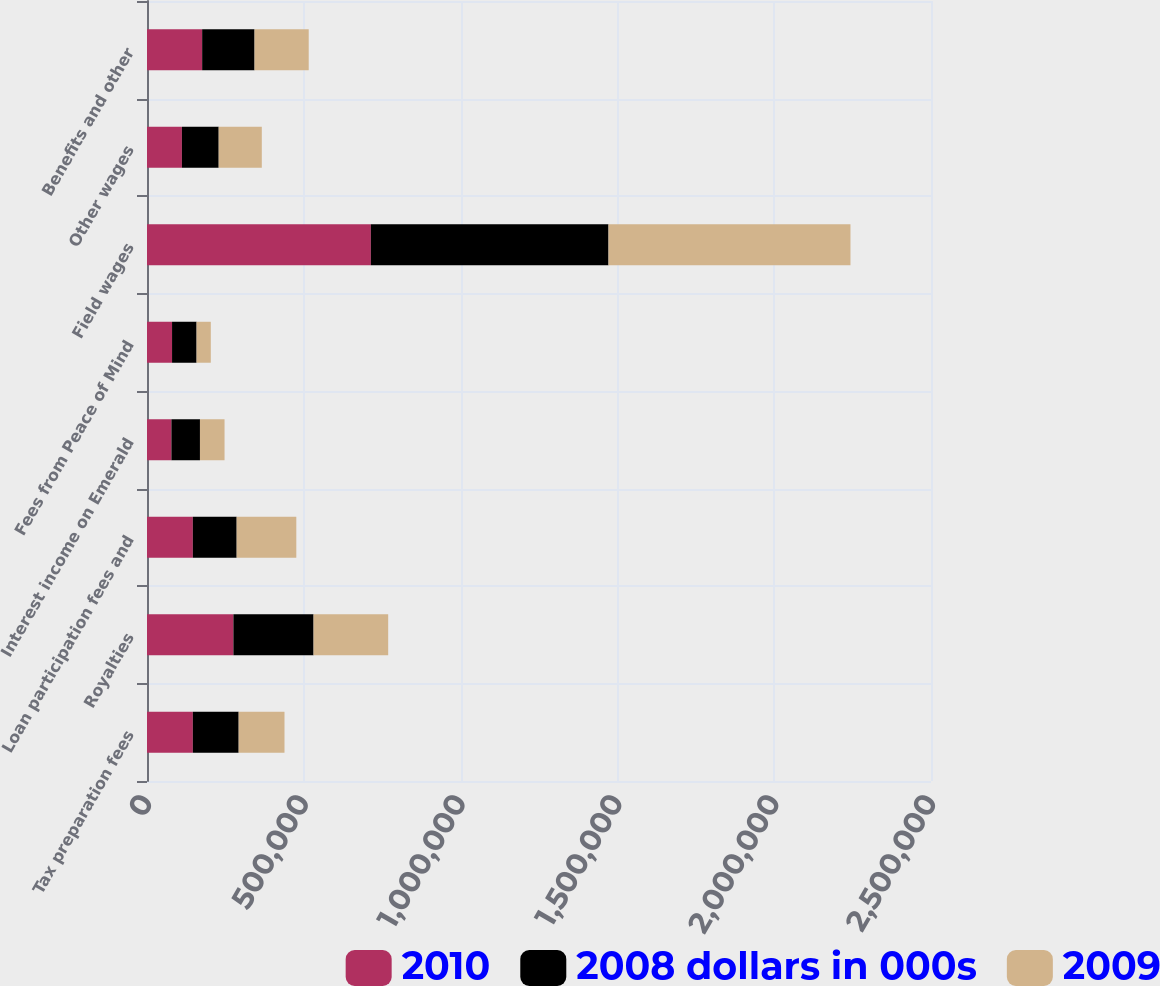Convert chart to OTSL. <chart><loc_0><loc_0><loc_500><loc_500><stacked_bar_chart><ecel><fcel>Tax preparation fees<fcel>Royalties<fcel>Loan participation fees and<fcel>Interest income on Emerald<fcel>Fees from Peace of Mind<fcel>Field wages<fcel>Other wages<fcel>Benefits and other<nl><fcel>2010<fcel>146160<fcel>275559<fcel>146160<fcel>77882<fcel>79888<fcel>713792<fcel>111326<fcel>175904<nl><fcel>2008 dollars in 000s<fcel>146160<fcel>255536<fcel>139770<fcel>91010<fcel>78205<fcel>757835<fcel>117291<fcel>167005<nl><fcel>2009<fcel>146160<fcel>237986<fcel>190201<fcel>78385<fcel>45339<fcel>771598<fcel>137457<fcel>172728<nl></chart> 